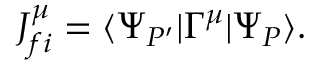Convert formula to latex. <formula><loc_0><loc_0><loc_500><loc_500>J _ { f i } ^ { \mu } = \langle \Psi _ { P ^ { \prime } } | \Gamma ^ { \mu } | \Psi _ { P } \rangle .</formula> 